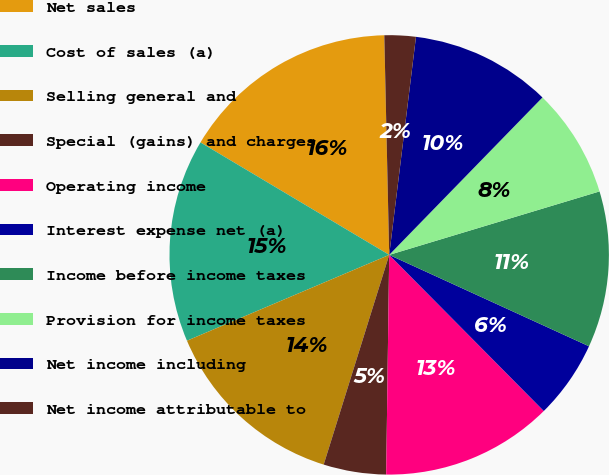<chart> <loc_0><loc_0><loc_500><loc_500><pie_chart><fcel>Net sales<fcel>Cost of sales (a)<fcel>Selling general and<fcel>Special (gains) and charges<fcel>Operating income<fcel>Interest expense net (a)<fcel>Income before income taxes<fcel>Provision for income taxes<fcel>Net income including<fcel>Net income attributable to<nl><fcel>16.09%<fcel>14.94%<fcel>13.79%<fcel>4.6%<fcel>12.64%<fcel>5.75%<fcel>11.49%<fcel>8.05%<fcel>10.34%<fcel>2.3%<nl></chart> 